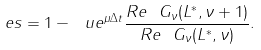<formula> <loc_0><loc_0><loc_500><loc_500>\ e s = 1 - \ u e ^ { \mu \Delta t } \frac { R e \ G _ { \nu } ( L ^ { * } , \nu + 1 ) } { R e \ G _ { \nu } ( L ^ { * } , \nu ) } .</formula> 